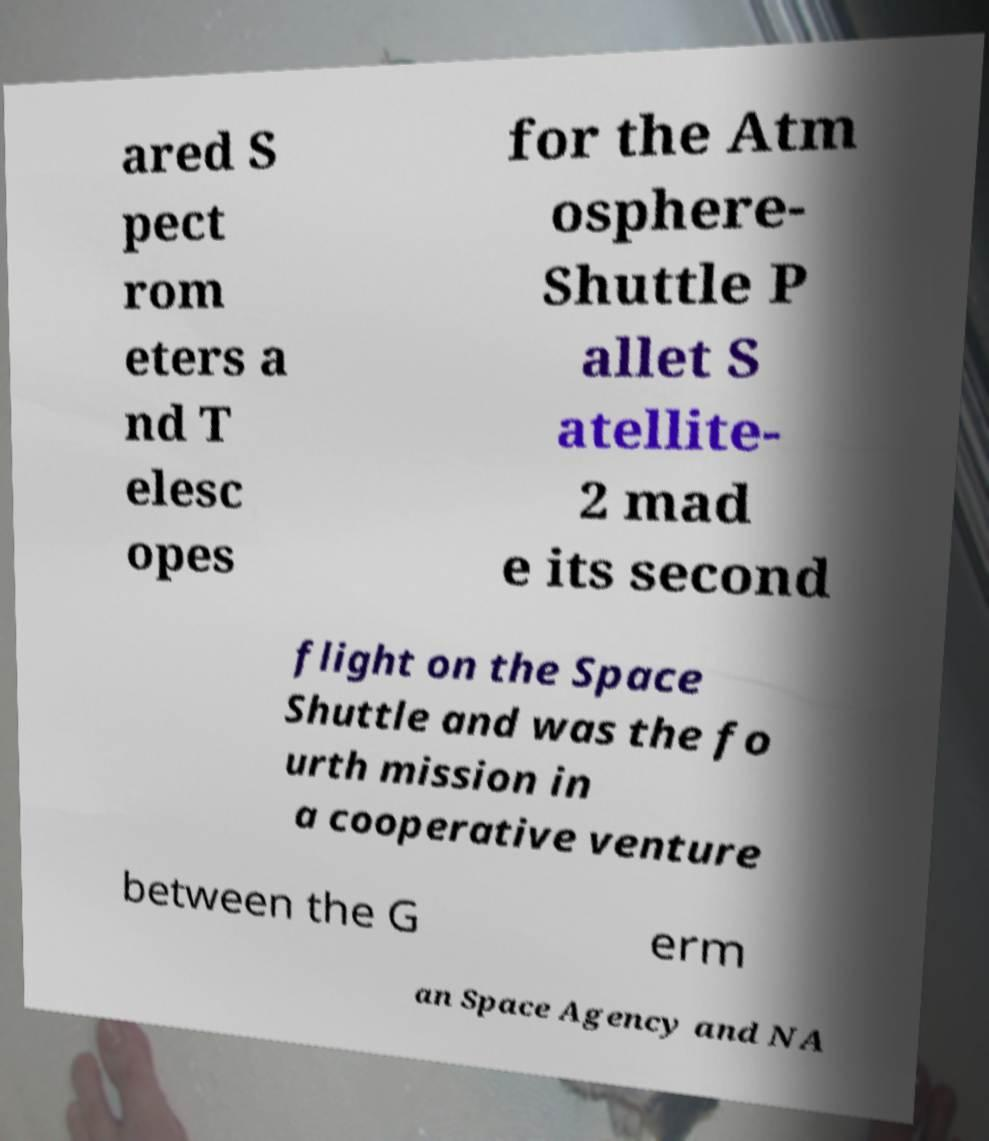Could you assist in decoding the text presented in this image and type it out clearly? ared S pect rom eters a nd T elesc opes for the Atm osphere- Shuttle P allet S atellite- 2 mad e its second flight on the Space Shuttle and was the fo urth mission in a cooperative venture between the G erm an Space Agency and NA 